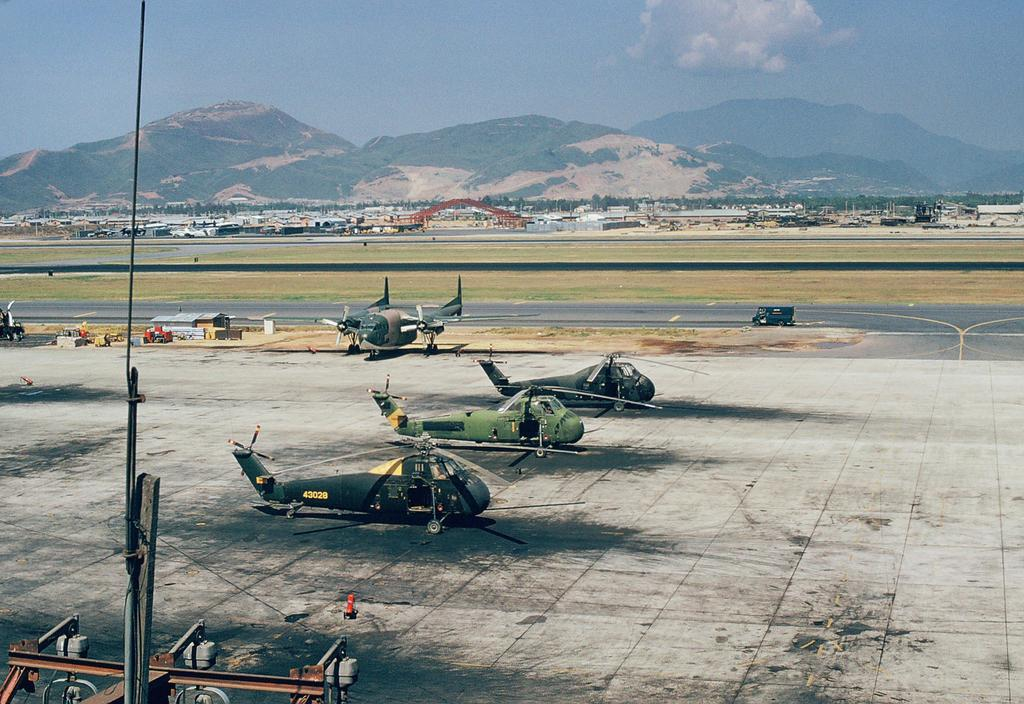What type of transportation can be seen on the surface in the image? There are airplanes on the surface in the image. What else can be seen in the background of the image? A vehicle is visible on the road, there is a crane, trees, hills, and the sky in the background of the image. What rate of fuel consumption can be observed for the children in the image? There are no children present in the image, and therefore no fuel consumption can be observed. 